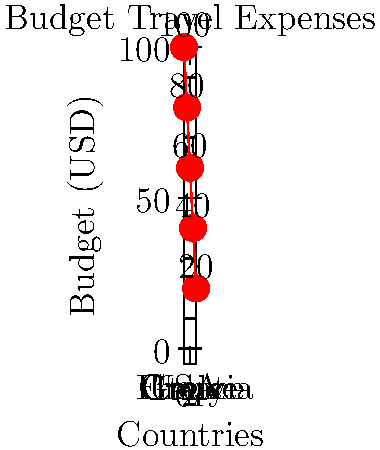You're planning a budget-friendly Euro trip after your college semester. The graph shows your daily budget in USD for each country. If the exchange rates are:
1 USD = 0.85 EUR
1 USD = 140 JPY
1 EUR = 165 JPY

How much would your total 5-day trip cost in Japanese Yen (JPY), assuming you spend exactly your daily budget in each country? Let's break this down step-by-step:

1) First, calculate the total budget in USD:
   USA: $100
   France: $80
   Italy: $60
   Greece: $40
   Croatia: $20
   Total per day: $100 + $80 + $60 + $40 + $20 = $300

2) For a 5-day trip, the total budget in USD is:
   $300 × 5 = $1500

3) Now, we need to convert $1500 to JPY. We can do this directly:
   $1 = 140 JPY
   $1500 = 1500 × 140 = 210,000 JPY

Alternatively, we could convert to EUR first and then to JPY:
   $1500 = 1500 × 0.85 = 1275 EUR
   1275 EUR = 1275 × 165 = 210,375 JPY

The slight difference is due to rounding in the exchange rates. We'll use the direct USD to JPY conversion for our final answer.
Answer: 210,000 JPY 